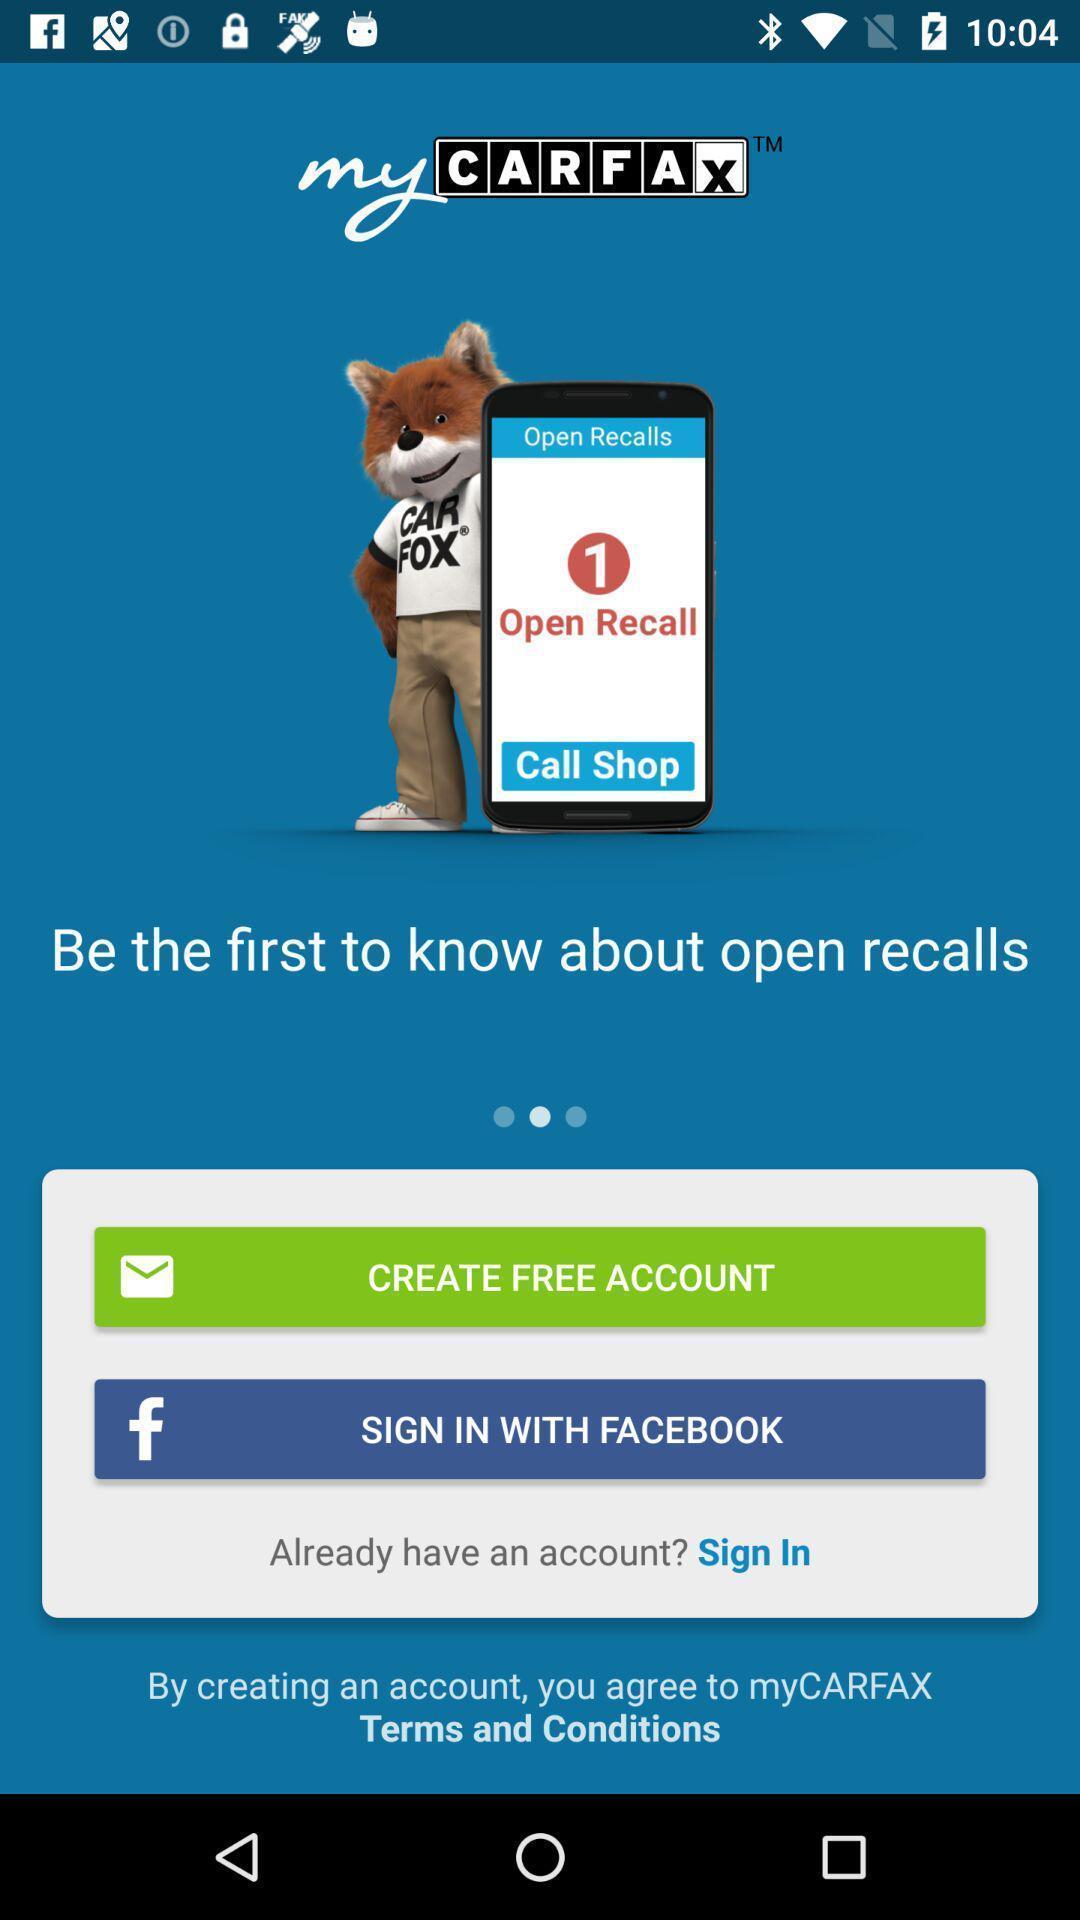Please provide a description for this image. Welcome page of a vehicle maintenance app. 